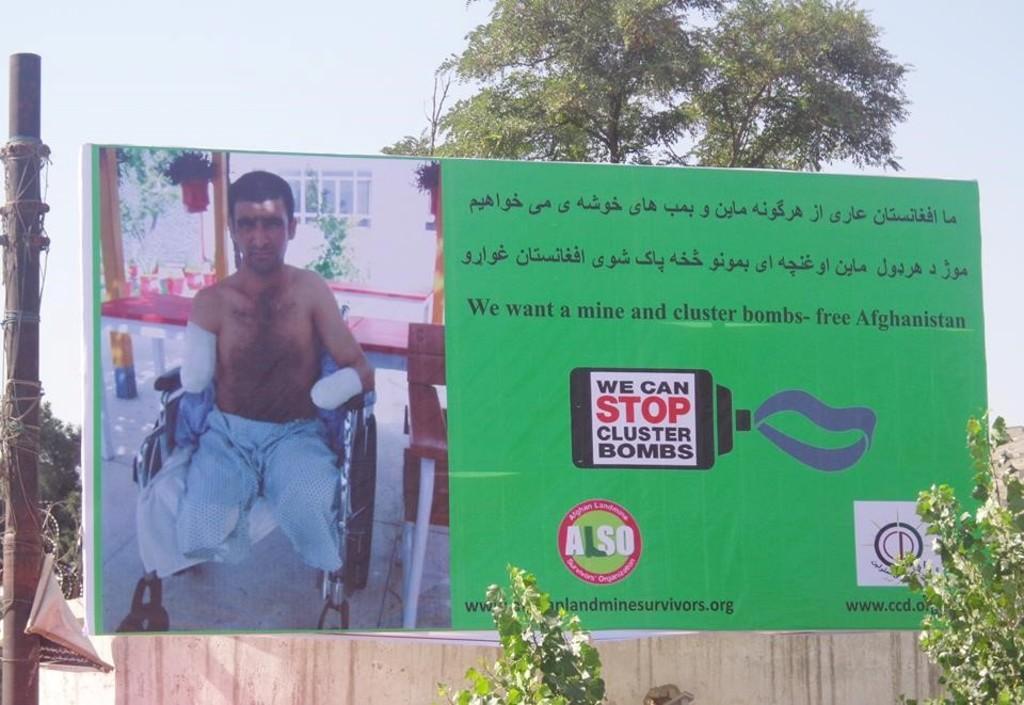Please provide a concise description of this image. In this image there a poster, on that poster there is some text and a picture and there are trees, pole, in the background there is tree and the sky. 